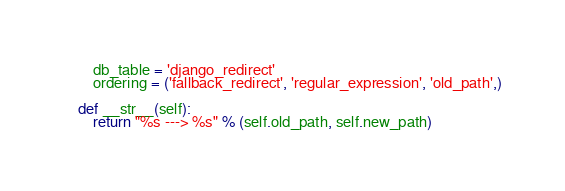<code> <loc_0><loc_0><loc_500><loc_500><_Python_>        db_table = 'django_redirect'
        ordering = ('fallback_redirect', 'regular_expression', 'old_path',)

    def __str__(self):
        return "%s ---> %s" % (self.old_path, self.new_path)
</code> 